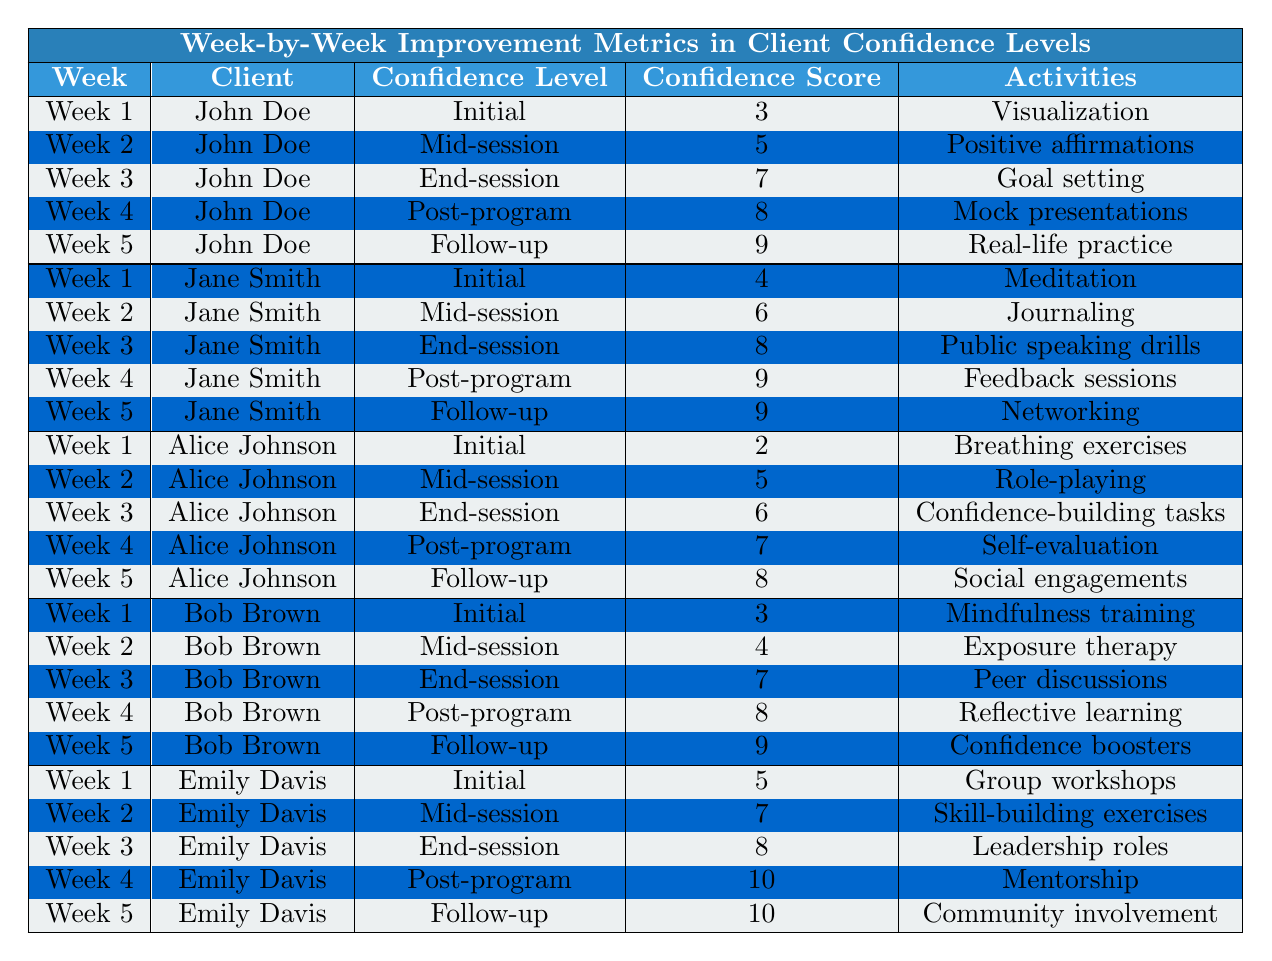What was John Doe's confidence score in Week 3? According to the table, John Doe's confidence score in Week 3 is 7.
Answer: 7 What activity did Emily Davis participate in during Week 4? The table indicates that Emily Davis participated in "Mentorship" during Week 4.
Answer: Mentorship How much did Jane Smith's confidence score improve from Week 1 to Week 5? Jane Smith's confidence score in Week 1 is 4, and in Week 5 it is 9. The improvement is calculated as 9 - 4 = 5.
Answer: 5 Which client had the lowest initial confidence score? Reviewing the table, Alice Johnson had the lowest initial confidence score of 2 in Week 1.
Answer: Alice Johnson For how many clients did the confidence score reach 10 by Week 5? By checking the table, Emily Davis is the only client who reached a confidence score of 10 by Week 5.
Answer: 1 What was the average confidence score for Bob Brown throughout the five weeks? Bob Brown's scores are 3, 4, 7, 8, and 9. The sum is 3 + 4 + 7 + 8 + 9 = 31. With 5 measurements, the average is 31 / 5 = 6.2.
Answer: 6.2 Did Alice Johnson's confidence score increase every week? Observing Alice Johnson's scores: 2 in Week 1, 5 in Week 2, 6 in Week 3, 7 in Week 4, and 8 in Week 5 shows consistent improvement. Therefore, it is true that her score increased every week.
Answer: Yes What activity was common to both John Doe and Jane Smith in Week 4? The table shows that John Doe's activity in Week 4 was "Mock presentations" and Jane Smith's was "Feedback sessions," which are different. Thus, there was no common activity for both in that week.
Answer: No common activity How does Alice Johnson's final score compare with the initial score of all clients? Alice Johnson's final score is 8 (Week 5), while the initial scores for John (3), Jane (4), Bob (3), and Emily (5) are all lower than her final score of 8. Hence, her final score is higher than all initial scores.
Answer: Higher than all initial scores Which client showed the greatest improvement from the initial to the follow-up stage? Evaluating improvements: John Doe (3 to 9 = 6), Jane Smith (4 to 9 = 5), Alice Johnson (2 to 8 = 6), Bob Brown (3 to 9 = 6), and Emily Davis (5 to 10 = 5). John Doe, Alice Johnson, and Bob Brown all show a 6-point increase, revealing a tie among them for the greatest improvement.
Answer: John Doe, Alice Johnson, and Bob Brown 